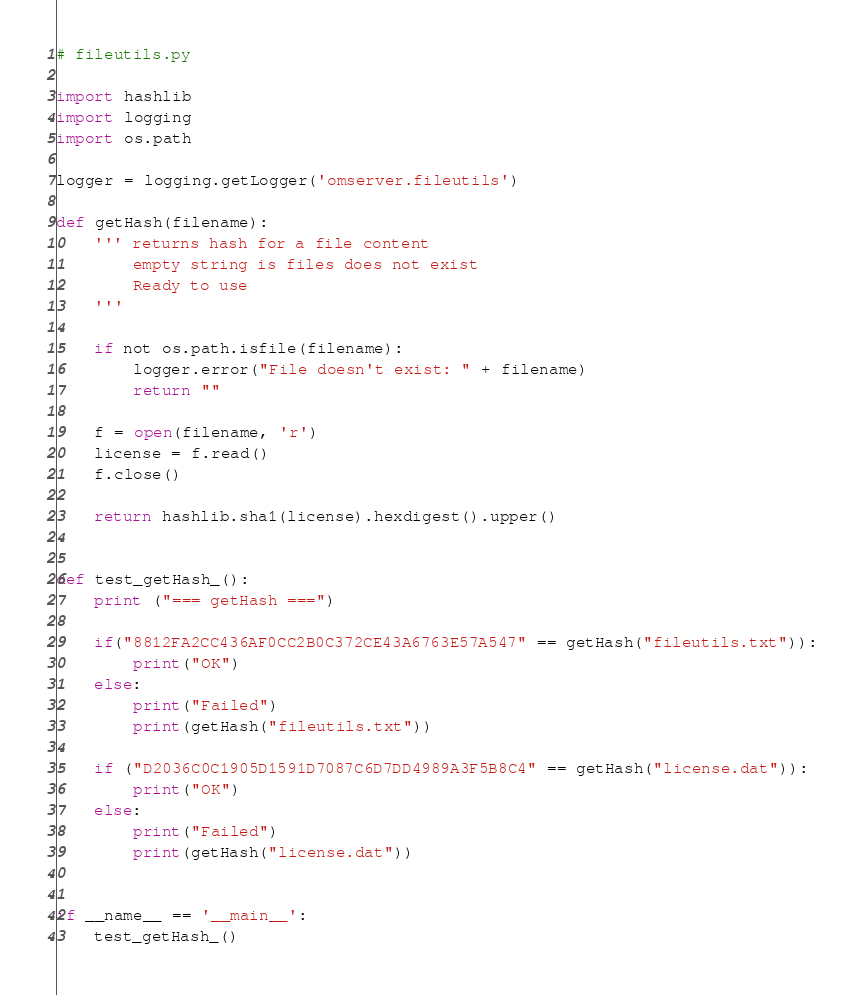Convert code to text. <code><loc_0><loc_0><loc_500><loc_500><_Python_># fileutils.py

import hashlib
import logging
import os.path

logger = logging.getLogger('omserver.fileutils')

def getHash(filename):
    ''' returns hash for a file content
        empty string is files does not exist
        Ready to use
    '''

    if not os.path.isfile(filename):
        logger.error("File doesn't exist: " + filename)
        return ""

    f = open(filename, 'r')
    license = f.read()
    f.close()

    return hashlib.sha1(license).hexdigest().upper()


def test_getHash_():
    print ("=== getHash ===")

    if("8812FA2CC436AF0CC2B0C372CE43A6763E57A547" == getHash("fileutils.txt")):
        print("OK")
    else:
        print("Failed")
        print(getHash("fileutils.txt"))

    if ("D2036C0C1905D1591D7087C6D7DD4989A3F5B8C4" == getHash("license.dat")):
        print("OK")
    else:
        print("Failed")
        print(getHash("license.dat"))


if __name__ == '__main__':
    test_getHash_()

</code> 